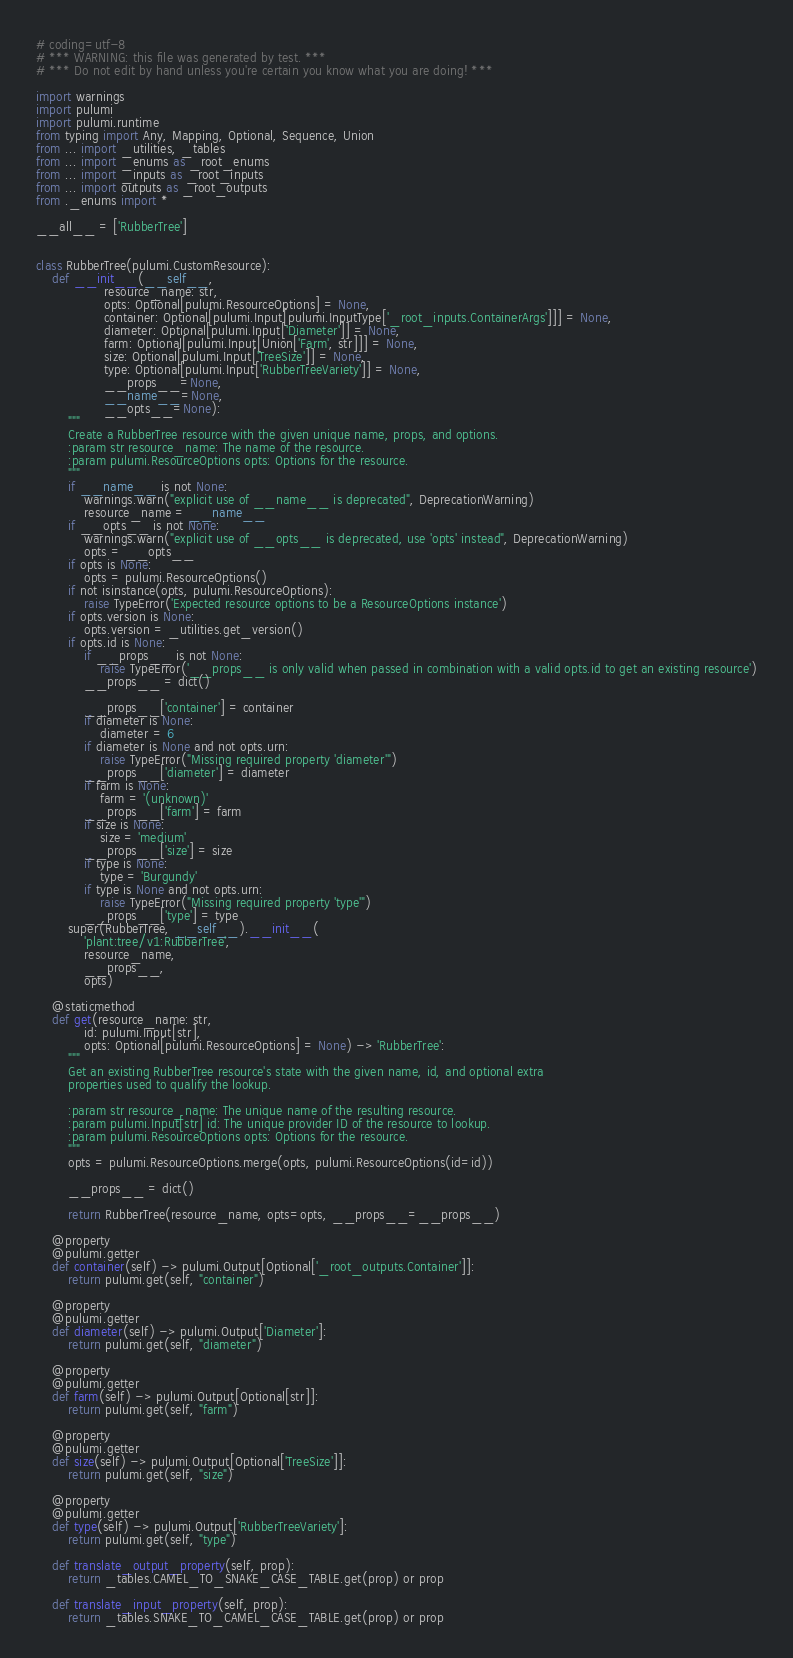Convert code to text. <code><loc_0><loc_0><loc_500><loc_500><_Python_># coding=utf-8
# *** WARNING: this file was generated by test. ***
# *** Do not edit by hand unless you're certain you know what you are doing! ***

import warnings
import pulumi
import pulumi.runtime
from typing import Any, Mapping, Optional, Sequence, Union
from ... import _utilities, _tables
from ... import _enums as _root_enums
from ... import _inputs as _root_inputs
from ... import outputs as _root_outputs
from ._enums import *

__all__ = ['RubberTree']


class RubberTree(pulumi.CustomResource):
    def __init__(__self__,
                 resource_name: str,
                 opts: Optional[pulumi.ResourceOptions] = None,
                 container: Optional[pulumi.Input[pulumi.InputType['_root_inputs.ContainerArgs']]] = None,
                 diameter: Optional[pulumi.Input['Diameter']] = None,
                 farm: Optional[pulumi.Input[Union['Farm', str]]] = None,
                 size: Optional[pulumi.Input['TreeSize']] = None,
                 type: Optional[pulumi.Input['RubberTreeVariety']] = None,
                 __props__=None,
                 __name__=None,
                 __opts__=None):
        """
        Create a RubberTree resource with the given unique name, props, and options.
        :param str resource_name: The name of the resource.
        :param pulumi.ResourceOptions opts: Options for the resource.
        """
        if __name__ is not None:
            warnings.warn("explicit use of __name__ is deprecated", DeprecationWarning)
            resource_name = __name__
        if __opts__ is not None:
            warnings.warn("explicit use of __opts__ is deprecated, use 'opts' instead", DeprecationWarning)
            opts = __opts__
        if opts is None:
            opts = pulumi.ResourceOptions()
        if not isinstance(opts, pulumi.ResourceOptions):
            raise TypeError('Expected resource options to be a ResourceOptions instance')
        if opts.version is None:
            opts.version = _utilities.get_version()
        if opts.id is None:
            if __props__ is not None:
                raise TypeError('__props__ is only valid when passed in combination with a valid opts.id to get an existing resource')
            __props__ = dict()

            __props__['container'] = container
            if diameter is None:
                diameter = 6
            if diameter is None and not opts.urn:
                raise TypeError("Missing required property 'diameter'")
            __props__['diameter'] = diameter
            if farm is None:
                farm = '(unknown)'
            __props__['farm'] = farm
            if size is None:
                size = 'medium'
            __props__['size'] = size
            if type is None:
                type = 'Burgundy'
            if type is None and not opts.urn:
                raise TypeError("Missing required property 'type'")
            __props__['type'] = type
        super(RubberTree, __self__).__init__(
            'plant:tree/v1:RubberTree',
            resource_name,
            __props__,
            opts)

    @staticmethod
    def get(resource_name: str,
            id: pulumi.Input[str],
            opts: Optional[pulumi.ResourceOptions] = None) -> 'RubberTree':
        """
        Get an existing RubberTree resource's state with the given name, id, and optional extra
        properties used to qualify the lookup.

        :param str resource_name: The unique name of the resulting resource.
        :param pulumi.Input[str] id: The unique provider ID of the resource to lookup.
        :param pulumi.ResourceOptions opts: Options for the resource.
        """
        opts = pulumi.ResourceOptions.merge(opts, pulumi.ResourceOptions(id=id))

        __props__ = dict()

        return RubberTree(resource_name, opts=opts, __props__=__props__)

    @property
    @pulumi.getter
    def container(self) -> pulumi.Output[Optional['_root_outputs.Container']]:
        return pulumi.get(self, "container")

    @property
    @pulumi.getter
    def diameter(self) -> pulumi.Output['Diameter']:
        return pulumi.get(self, "diameter")

    @property
    @pulumi.getter
    def farm(self) -> pulumi.Output[Optional[str]]:
        return pulumi.get(self, "farm")

    @property
    @pulumi.getter
    def size(self) -> pulumi.Output[Optional['TreeSize']]:
        return pulumi.get(self, "size")

    @property
    @pulumi.getter
    def type(self) -> pulumi.Output['RubberTreeVariety']:
        return pulumi.get(self, "type")

    def translate_output_property(self, prop):
        return _tables.CAMEL_TO_SNAKE_CASE_TABLE.get(prop) or prop

    def translate_input_property(self, prop):
        return _tables.SNAKE_TO_CAMEL_CASE_TABLE.get(prop) or prop

</code> 